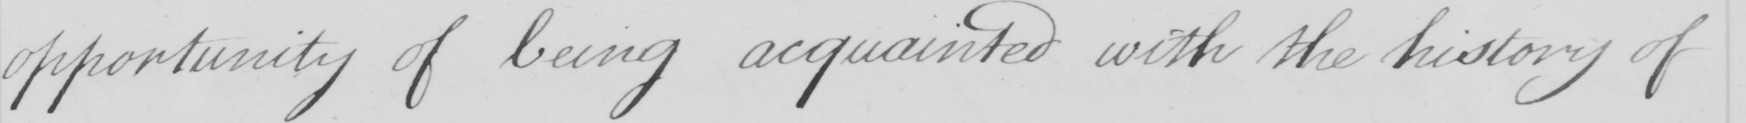What is written in this line of handwriting? opportunity of being acquainted with the history of 